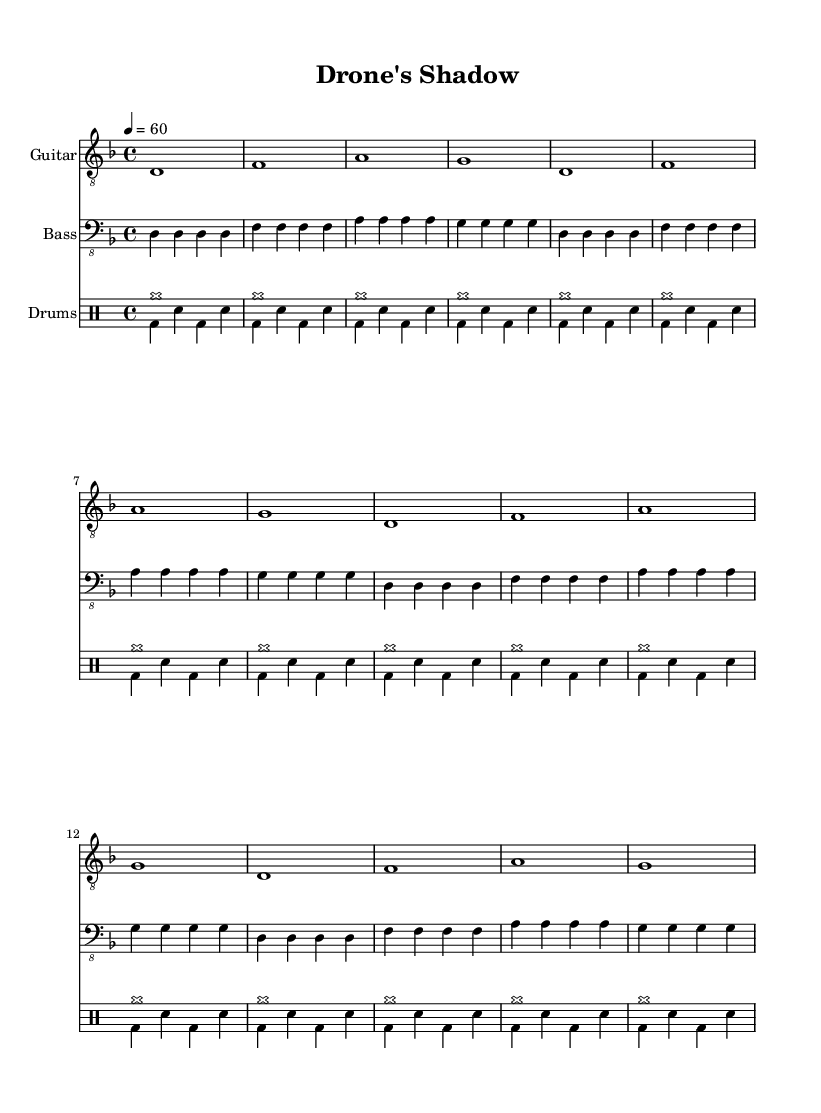What is the key signature of this music? The key signature indicates the presence of one flat, which corresponds to D minor.
Answer: D minor What is the time signature of this music? The time signature is shown at the beginning of the score, represented as 4/4, meaning there are four beats in each measure.
Answer: 4/4 What is the tempo marking for this piece? The tempo is indicated in the score as "4 = 60," meaning there are 60 quarter note beats per minute.
Answer: 60 How many measures does the guitar part repeat? The guitar section consists of a sequence that is indicated to repeat four times, specified as "\repeat unfold 4."
Answer: 4 What type of rhythm does the drum section primarily use? The drum section alternates between cymbal hits and a steady bass-snare pattern, reflecting typical metal drumming styles that emphasize heavy beats.
Answer: Alternating What is the function of the bass guitar in this piece? The bass guitar reinforces the harmonic foundation by playing the root notes of the chords, mirroring the guitar's melodic structure without adding complexity.
Answer: Reinforce harmony How is the psychological impact of modern warfare represented in this composition? The composition likely employs dark tonality and heavy instrumentation to evoke feelings of despair and tension, which captures the psychological weight of drone warfare.
Answer: Dark tonality 